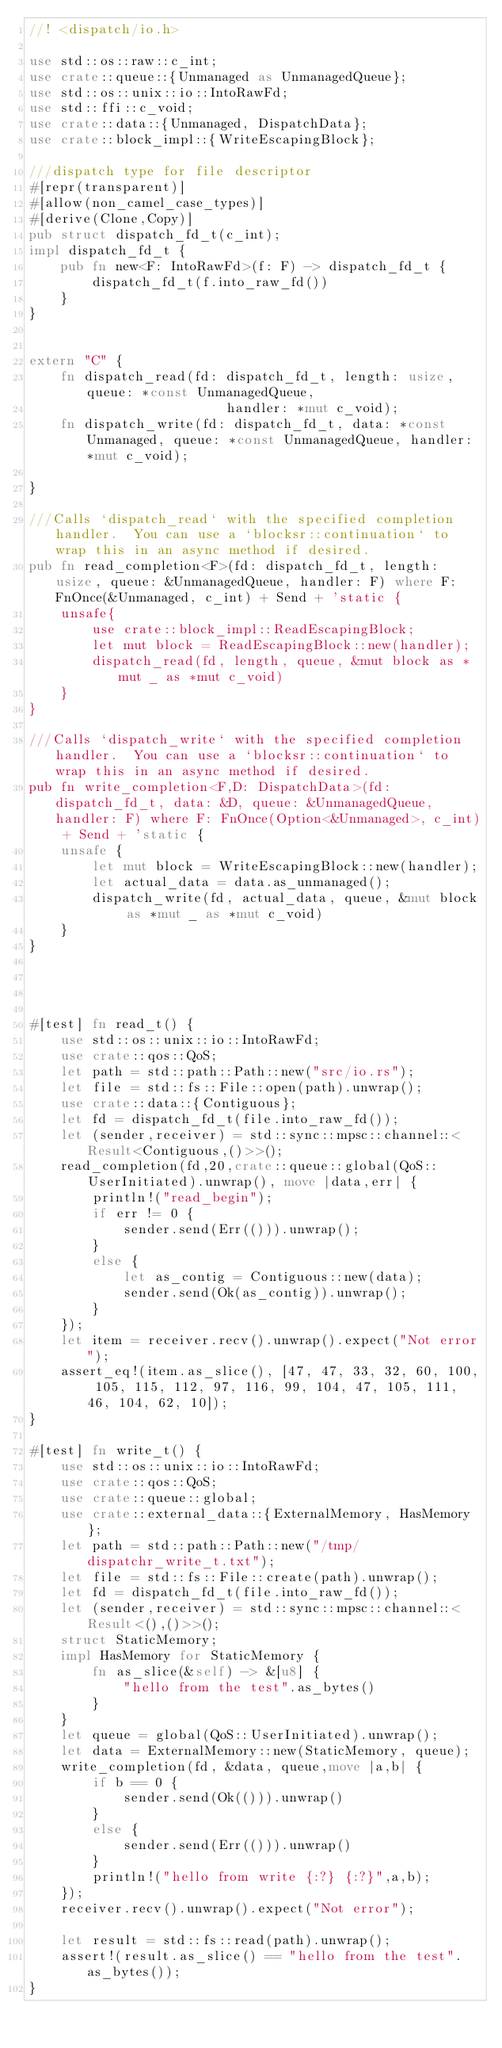<code> <loc_0><loc_0><loc_500><loc_500><_Rust_>//! <dispatch/io.h>

use std::os::raw::c_int;
use crate::queue::{Unmanaged as UnmanagedQueue};
use std::os::unix::io::IntoRawFd;
use std::ffi::c_void;
use crate::data::{Unmanaged, DispatchData};
use crate::block_impl::{WriteEscapingBlock};

///dispatch type for file descriptor
#[repr(transparent)]
#[allow(non_camel_case_types)]
#[derive(Clone,Copy)]
pub struct dispatch_fd_t(c_int);
impl dispatch_fd_t {
    pub fn new<F: IntoRawFd>(f: F) -> dispatch_fd_t {
        dispatch_fd_t(f.into_raw_fd())
    }
}


extern "C" {
    fn dispatch_read(fd: dispatch_fd_t, length: usize, queue: *const UnmanagedQueue,
                         handler: *mut c_void);
    fn dispatch_write(fd: dispatch_fd_t, data: *const Unmanaged, queue: *const UnmanagedQueue, handler: *mut c_void);

}

///Calls `dispatch_read` with the specified completion handler.  You can use a `blocksr::continuation` to wrap this in an async method if desired.
pub fn read_completion<F>(fd: dispatch_fd_t, length: usize, queue: &UnmanagedQueue, handler: F) where F: FnOnce(&Unmanaged, c_int) + Send + 'static {
    unsafe{
        use crate::block_impl::ReadEscapingBlock;
        let mut block = ReadEscapingBlock::new(handler);
        dispatch_read(fd, length, queue, &mut block as *mut _ as *mut c_void)
    }
}

///Calls `dispatch_write` with the specified completion handler.  You can use a `blocksr::continuation` to wrap this in an async method if desired.
pub fn write_completion<F,D: DispatchData>(fd: dispatch_fd_t, data: &D, queue: &UnmanagedQueue, handler: F) where F: FnOnce(Option<&Unmanaged>, c_int) + Send + 'static {
    unsafe {
        let mut block = WriteEscapingBlock::new(handler);
        let actual_data = data.as_unmanaged();
        dispatch_write(fd, actual_data, queue, &mut block as *mut _ as *mut c_void)
    }
}




#[test] fn read_t() {
    use std::os::unix::io::IntoRawFd;
    use crate::qos::QoS;
    let path = std::path::Path::new("src/io.rs");
    let file = std::fs::File::open(path).unwrap();
    use crate::data::{Contiguous};
    let fd = dispatch_fd_t(file.into_raw_fd());
    let (sender,receiver) = std::sync::mpsc::channel::<Result<Contiguous,()>>();
    read_completion(fd,20,crate::queue::global(QoS::UserInitiated).unwrap(), move |data,err| {
        println!("read_begin");
        if err != 0 {
            sender.send(Err(())).unwrap();
        }
        else {
            let as_contig = Contiguous::new(data);
            sender.send(Ok(as_contig)).unwrap();
        }
    });
    let item = receiver.recv().unwrap().expect("Not error");
    assert_eq!(item.as_slice(), [47, 47, 33, 32, 60, 100, 105, 115, 112, 97, 116, 99, 104, 47, 105, 111, 46, 104, 62, 10]);
}

#[test] fn write_t() {
    use std::os::unix::io::IntoRawFd;
    use crate::qos::QoS;
    use crate::queue::global;
    use crate::external_data::{ExternalMemory, HasMemory};
    let path = std::path::Path::new("/tmp/dispatchr_write_t.txt");
    let file = std::fs::File::create(path).unwrap();
    let fd = dispatch_fd_t(file.into_raw_fd());
    let (sender,receiver) = std::sync::mpsc::channel::<Result<(),()>>();
    struct StaticMemory;
    impl HasMemory for StaticMemory {
        fn as_slice(&self) -> &[u8] {
            "hello from the test".as_bytes()
        }
    }
    let queue = global(QoS::UserInitiated).unwrap();
    let data = ExternalMemory::new(StaticMemory, queue);
    write_completion(fd, &data, queue,move |a,b| {
        if b == 0 {
            sender.send(Ok(())).unwrap()
        }
        else {
            sender.send(Err(())).unwrap()
        }
        println!("hello from write {:?} {:?}",a,b);
    });
    receiver.recv().unwrap().expect("Not error");

    let result = std::fs::read(path).unwrap();
    assert!(result.as_slice() == "hello from the test".as_bytes());
}

</code> 